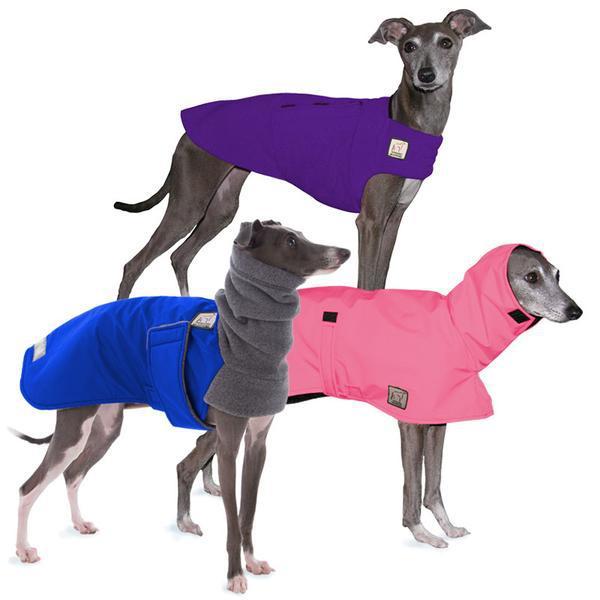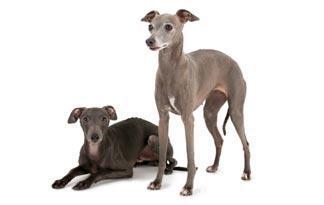The first image is the image on the left, the second image is the image on the right. For the images displayed, is the sentence "At least one of the dogs is wearing some type of material." factually correct? Answer yes or no. Yes. The first image is the image on the left, the second image is the image on the right. For the images shown, is this caption "In total, more than one dog is wearing something around its neck." true? Answer yes or no. Yes. 